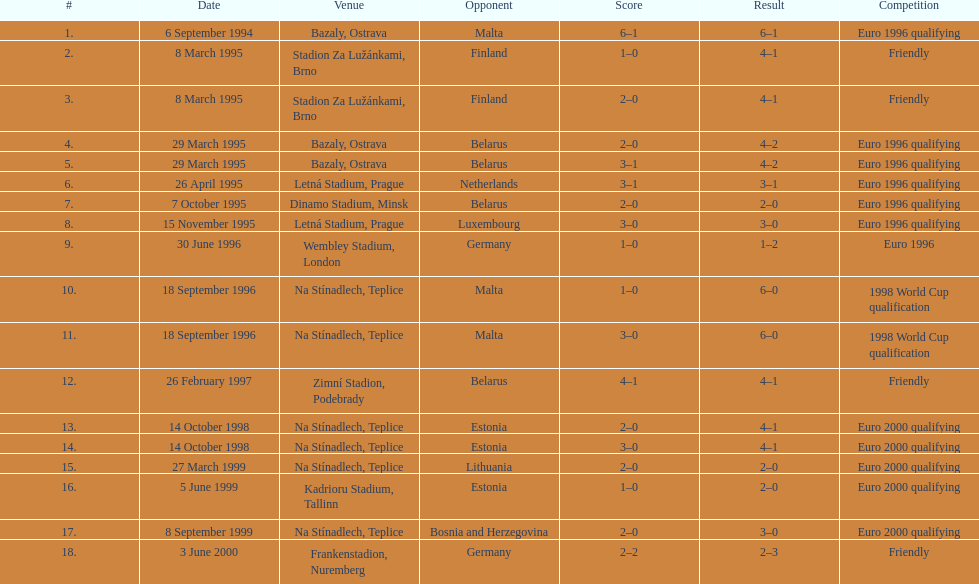Determine the adversary that yielded the smallest result from all outcomes. Germany. 